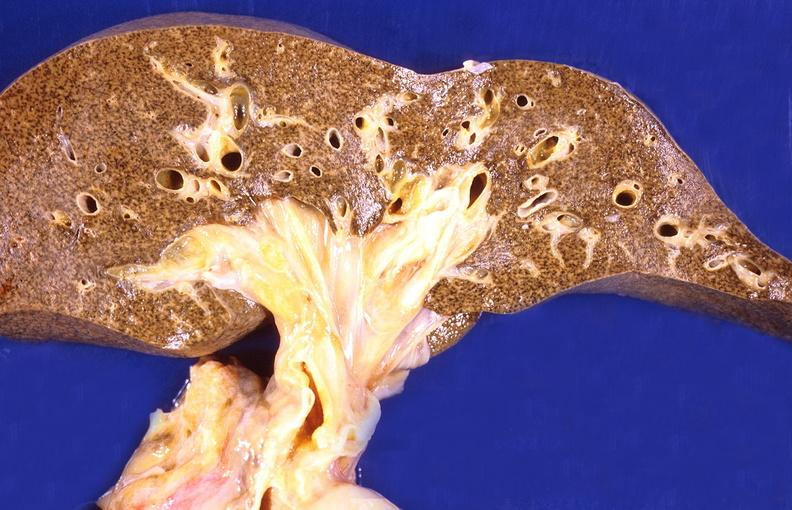what is present?
Answer the question using a single word or phrase. Hepatobiliary 